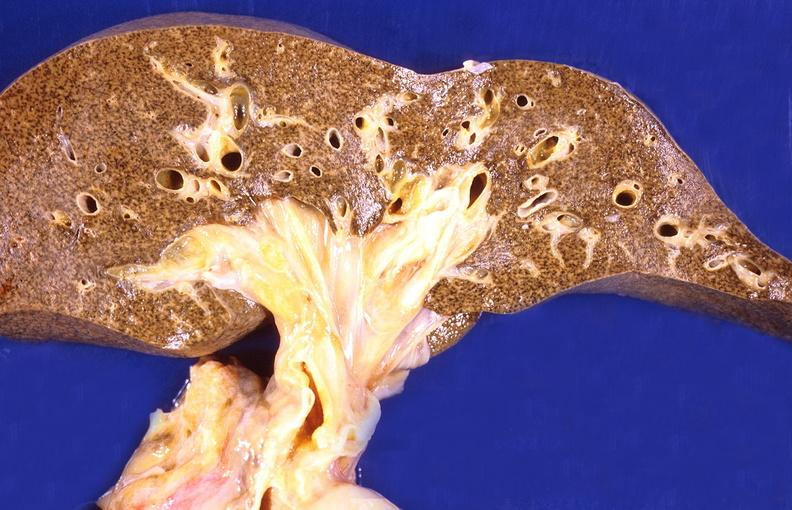what is present?
Answer the question using a single word or phrase. Hepatobiliary 